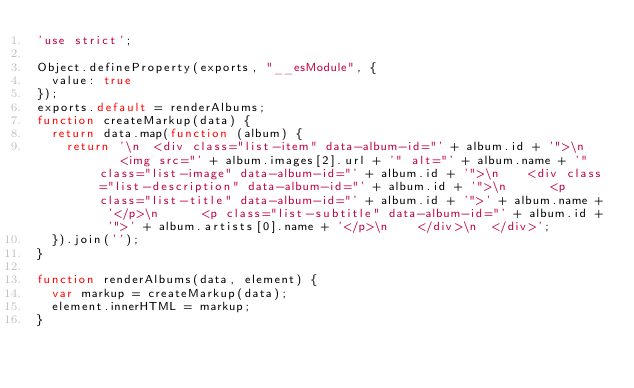<code> <loc_0><loc_0><loc_500><loc_500><_JavaScript_>'use strict';

Object.defineProperty(exports, "__esModule", {
  value: true
});
exports.default = renderAlbums;
function createMarkup(data) {
  return data.map(function (album) {
    return '\n  <div class="list-item" data-album-id="' + album.id + '">\n    <img src="' + album.images[2].url + '" alt="' + album.name + '" class="list-image" data-album-id="' + album.id + '">\n    <div class="list-description" data-album-id="' + album.id + '">\n      <p class="list-title" data-album-id="' + album.id + '">' + album.name + '</p>\n      <p class="list-subtitle" data-album-id="' + album.id + '">' + album.artists[0].name + '</p>\n    </div>\n  </div>';
  }).join('');
}

function renderAlbums(data, element) {
  var markup = createMarkup(data);
  element.innerHTML = markup;
}</code> 